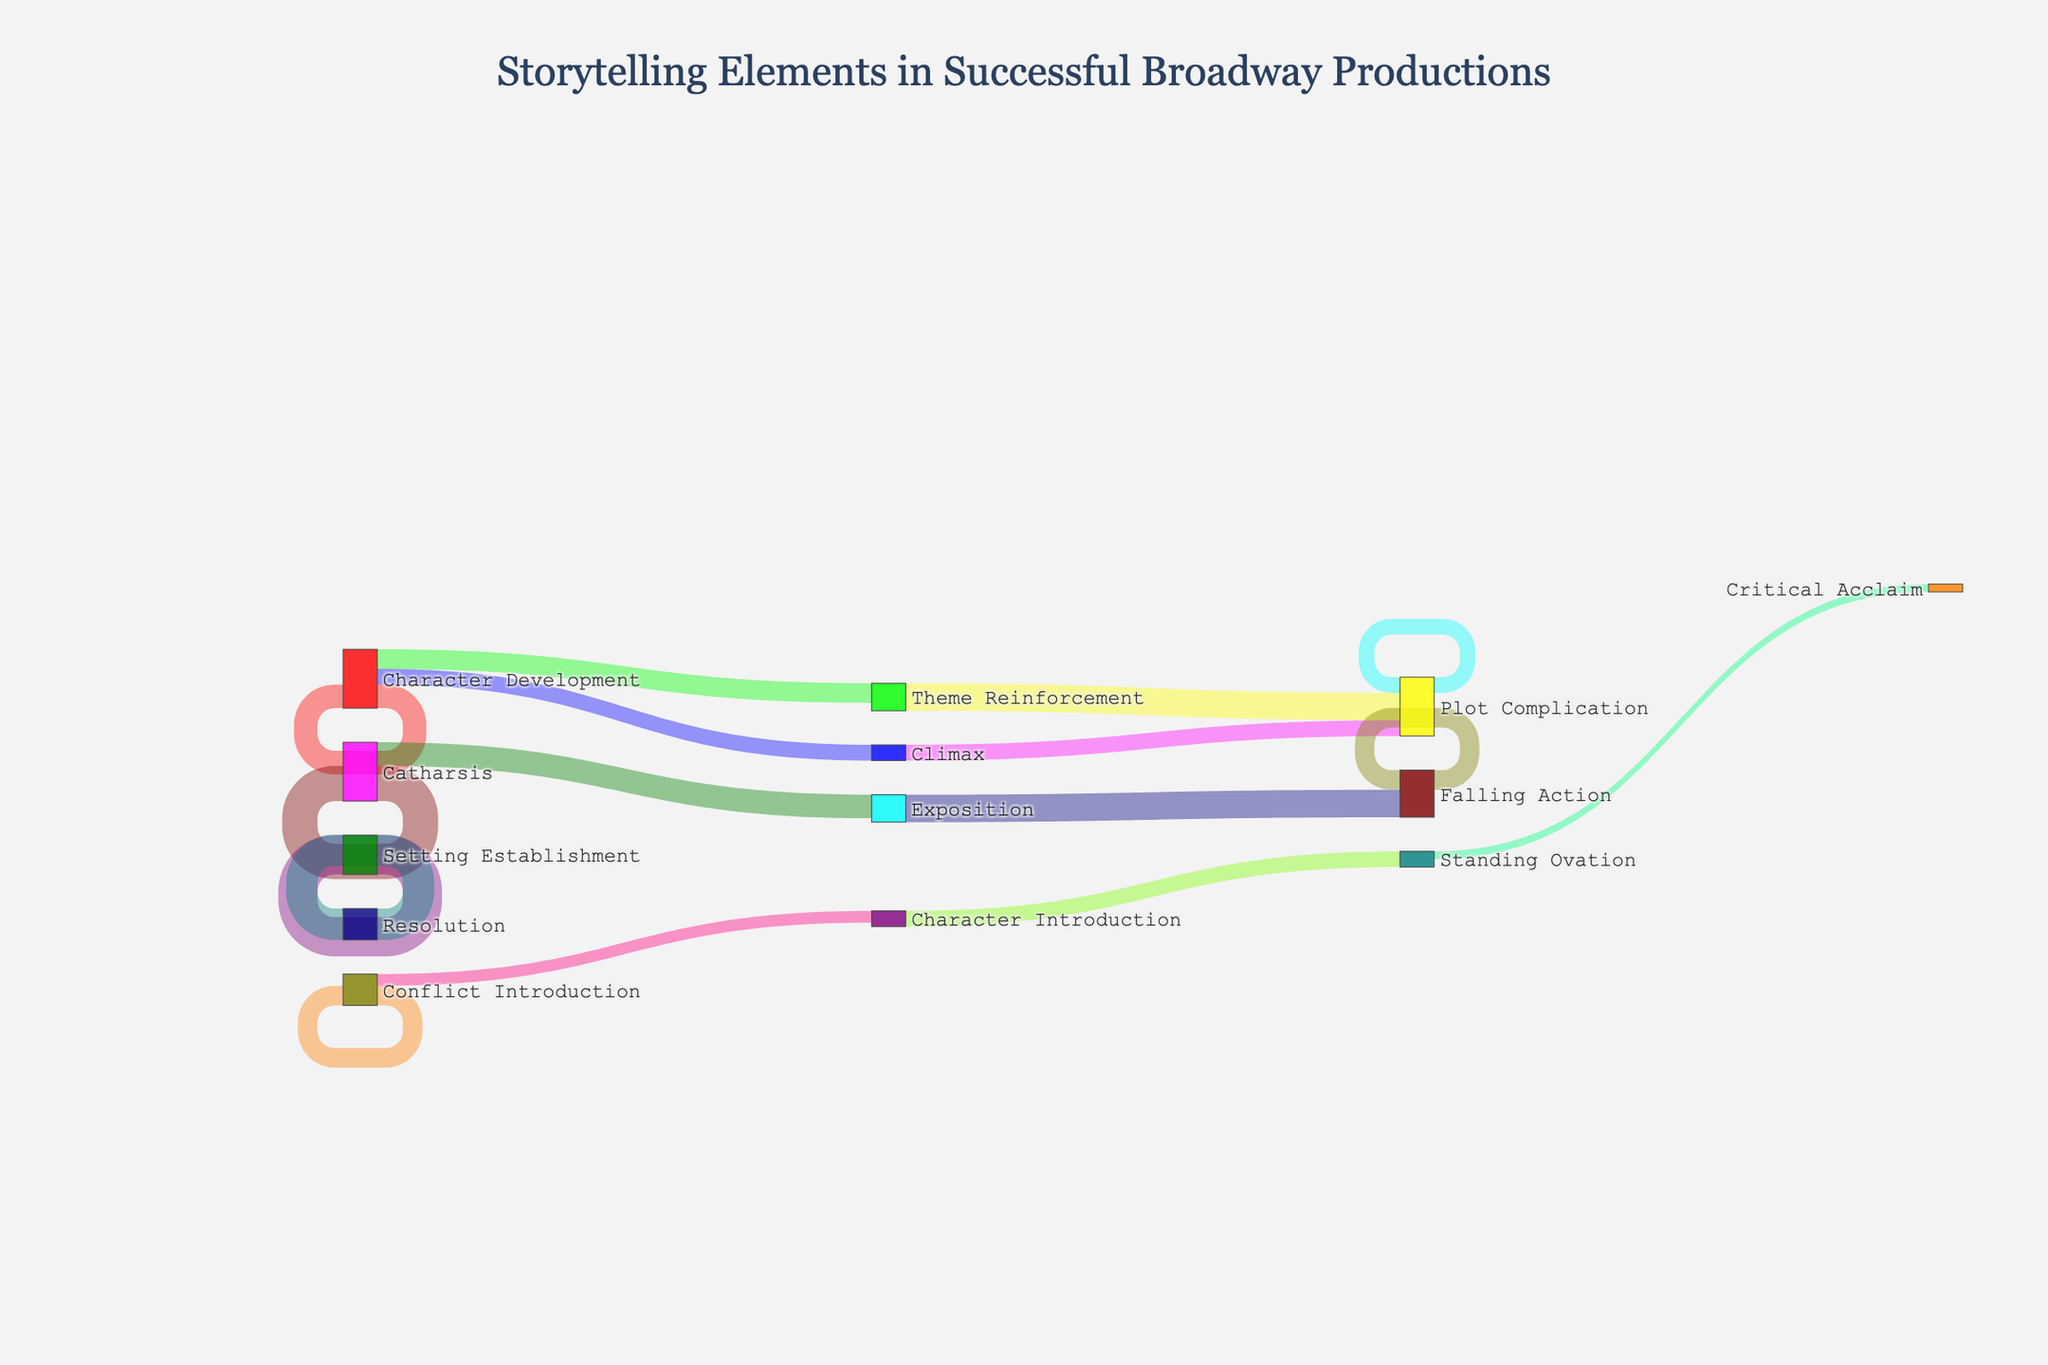What elements make up the exposition stage in successful Broadway productions? The exposition stage consists of character introduction, setting establishment, and conflict introduction. This information is derived from the flow of nodes and links from the "Exposition" node to its subsequent nodes.
Answer: Character introduction, setting establishment, conflict introduction Which storytelling element has the highest value flowing into the climax? By examining the diagram, we see two elements flowing into the climax: plot complication (35) and character development (25). Comparing these values, plot complication has the highest flow.
Answer: Plot complication How much total flow results in the climax stage? To find the total flow into the climax stage, sum the values from plot complication (35) and character development (25). 35 + 25 = 60.
Answer: 60 Compare the values flowing from the rising action stage. Which has the highest value? The rising action stage flows into plot complication (45) and character development (30). Comparing these, plot complication has the highest value.
Answer: Plot complication Which storytelling element has the most value flowing directly to the resolution stage? We need to look at what flows into the resolution stage. The diagram shows falling action flowing into the resolution with a value of 40. No other direct flows into resolution are mentioned.
Answer: Falling action What is the combined value of character introduction and conflict introduction flowing into the rising action stage? Sum the values from character introduction (35) and conflict introduction (20) into the rising action stage. 35 + 20 = 55.
Answer: 55 Is the value flowing from the catharsis stage to the standing ovation greater than the value flowing from the theme reinforcement stage to critical acclaim? From the diagram, catharsis flows into standing ovation with a value of 20, while theme reinforcement flows to critical acclaim with a value of 10. 20 is greater than 10.
Answer: Yes Identify the stages that lead to the falling action stage. The falling action stage is reached directly from the climax stage, based on the flow of values in the diagram.
Answer: Climax What is the least value flowing out of any stage, and which stage does it belong to? By scanning the values flowing out of each stage, the value 10 flowing from theme reinforcement to critical acclaim is the smallest.
Answer: 10, theme reinforcement 